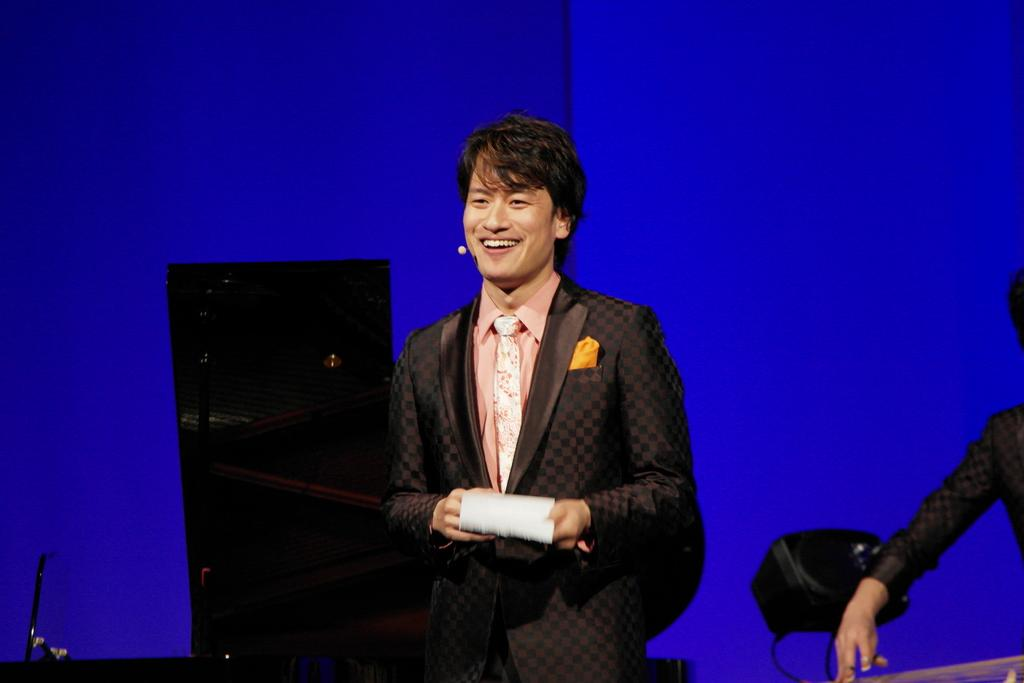What is the person in the image doing? There is a person standing in the image. What is the person wearing? The person is wearing a suit. What is the person holding in their hand? The person is holding an object in their hand. Can you describe the hand on the right side of the image? There is a hand of a person on the right side of the image. What color is the background of the image? The background of the image is blue. What type of vest can be seen on the squirrel in the image? There is no squirrel present in the image, and therefore no vest can be seen. 